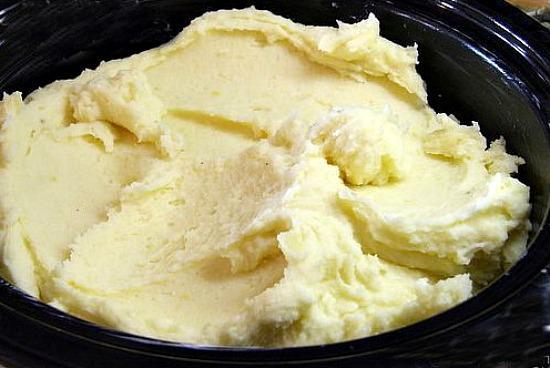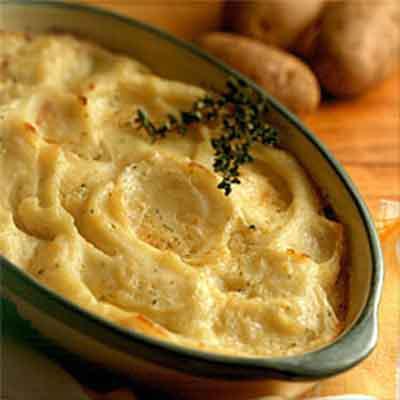The first image is the image on the left, the second image is the image on the right. Given the left and right images, does the statement "the casserole dish on the image in the right side is rectangular and white." hold true? Answer yes or no. No. The first image is the image on the left, the second image is the image on the right. For the images displayed, is the sentence "A casserole is in a white rectangular baking dish with chopped green chives on top." factually correct? Answer yes or no. No. 